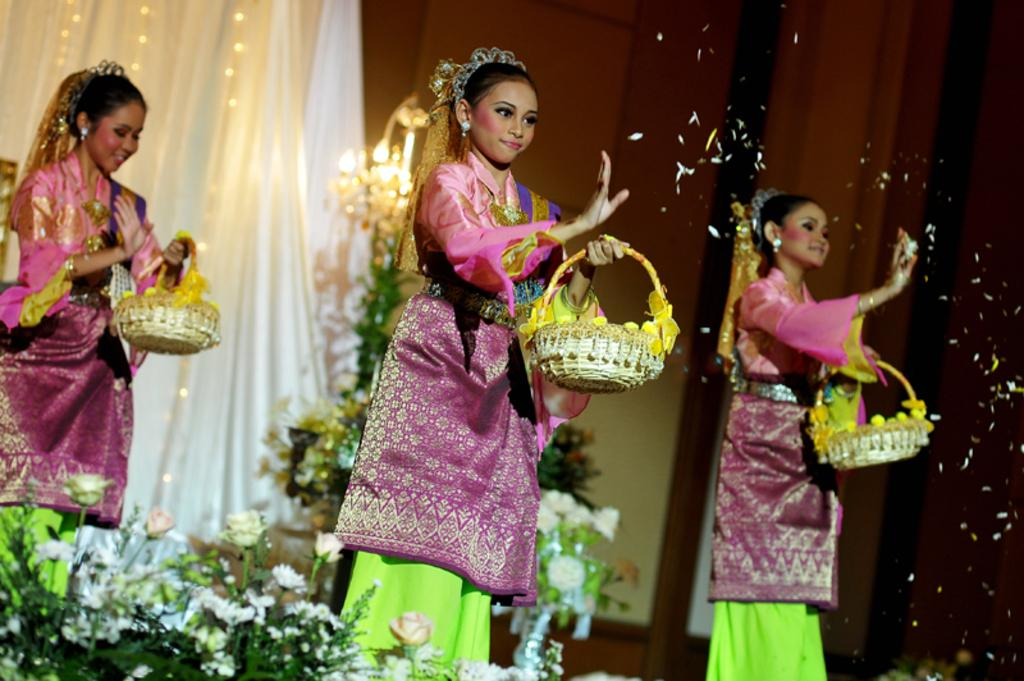How many girls are on the stage in the image? There are three girls on the stage in the image. What are the girls holding in the image? The girls are holding baskets in the image. What type of plants can be seen in the image? There are plants with flowers in the image. What is located on the backside of the stage? There is a curtain with lights on the backside of the stage. What type of music can be heard coming from the coil in the image? There is no coil or music present in the image. What type of drink is being served by the girls on the stage? The girls are holding baskets, not drinks, in the image. 